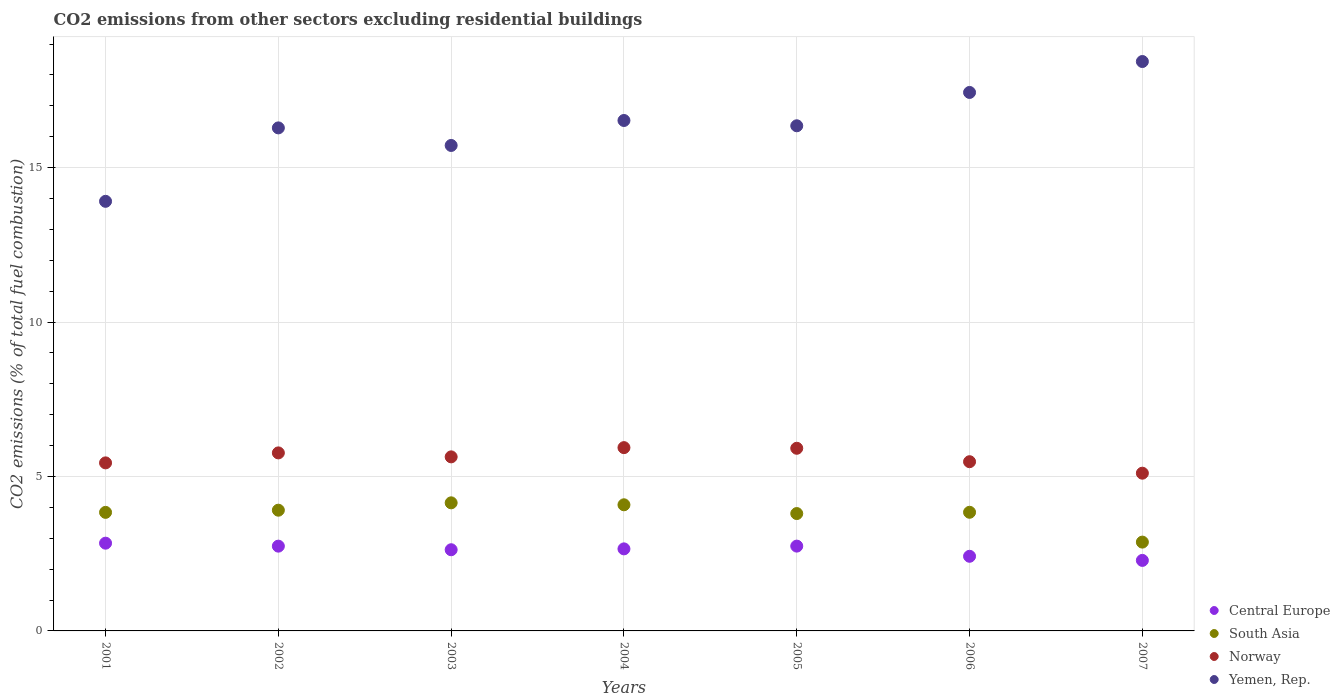How many different coloured dotlines are there?
Keep it short and to the point. 4. Is the number of dotlines equal to the number of legend labels?
Keep it short and to the point. Yes. What is the total CO2 emitted in Yemen, Rep. in 2007?
Offer a very short reply. 18.43. Across all years, what is the maximum total CO2 emitted in Central Europe?
Offer a very short reply. 2.84. Across all years, what is the minimum total CO2 emitted in South Asia?
Offer a terse response. 2.88. In which year was the total CO2 emitted in Norway maximum?
Make the answer very short. 2004. What is the total total CO2 emitted in Yemen, Rep. in the graph?
Offer a terse response. 114.66. What is the difference between the total CO2 emitted in South Asia in 2003 and that in 2004?
Your answer should be very brief. 0.06. What is the difference between the total CO2 emitted in Norway in 2003 and the total CO2 emitted in Yemen, Rep. in 2001?
Your answer should be compact. -8.27. What is the average total CO2 emitted in Central Europe per year?
Give a very brief answer. 2.62. In the year 2004, what is the difference between the total CO2 emitted in Norway and total CO2 emitted in Yemen, Rep.?
Make the answer very short. -10.59. What is the ratio of the total CO2 emitted in South Asia in 2004 to that in 2006?
Make the answer very short. 1.06. Is the total CO2 emitted in Norway in 2003 less than that in 2004?
Your response must be concise. Yes. What is the difference between the highest and the second highest total CO2 emitted in Central Europe?
Offer a terse response. 0.09. What is the difference between the highest and the lowest total CO2 emitted in Yemen, Rep.?
Ensure brevity in your answer.  4.53. In how many years, is the total CO2 emitted in Yemen, Rep. greater than the average total CO2 emitted in Yemen, Rep. taken over all years?
Your answer should be compact. 3. Is the sum of the total CO2 emitted in South Asia in 2005 and 2007 greater than the maximum total CO2 emitted in Yemen, Rep. across all years?
Keep it short and to the point. No. Is it the case that in every year, the sum of the total CO2 emitted in Yemen, Rep. and total CO2 emitted in Norway  is greater than the sum of total CO2 emitted in Central Europe and total CO2 emitted in South Asia?
Your response must be concise. No. Does the total CO2 emitted in Norway monotonically increase over the years?
Provide a short and direct response. No. Is the total CO2 emitted in Norway strictly greater than the total CO2 emitted in Central Europe over the years?
Your response must be concise. Yes. Is the total CO2 emitted in South Asia strictly less than the total CO2 emitted in Central Europe over the years?
Offer a terse response. No. How many dotlines are there?
Offer a terse response. 4. What is the difference between two consecutive major ticks on the Y-axis?
Your answer should be very brief. 5. Are the values on the major ticks of Y-axis written in scientific E-notation?
Ensure brevity in your answer.  No. Does the graph contain any zero values?
Keep it short and to the point. No. How many legend labels are there?
Your answer should be very brief. 4. How are the legend labels stacked?
Provide a short and direct response. Vertical. What is the title of the graph?
Give a very brief answer. CO2 emissions from other sectors excluding residential buildings. What is the label or title of the Y-axis?
Ensure brevity in your answer.  CO2 emissions (% of total fuel combustion). What is the CO2 emissions (% of total fuel combustion) in Central Europe in 2001?
Provide a succinct answer. 2.84. What is the CO2 emissions (% of total fuel combustion) of South Asia in 2001?
Make the answer very short. 3.84. What is the CO2 emissions (% of total fuel combustion) in Norway in 2001?
Your answer should be very brief. 5.44. What is the CO2 emissions (% of total fuel combustion) in Yemen, Rep. in 2001?
Ensure brevity in your answer.  13.91. What is the CO2 emissions (% of total fuel combustion) of Central Europe in 2002?
Offer a terse response. 2.74. What is the CO2 emissions (% of total fuel combustion) of South Asia in 2002?
Make the answer very short. 3.91. What is the CO2 emissions (% of total fuel combustion) in Norway in 2002?
Provide a succinct answer. 5.76. What is the CO2 emissions (% of total fuel combustion) in Yemen, Rep. in 2002?
Your answer should be compact. 16.29. What is the CO2 emissions (% of total fuel combustion) in Central Europe in 2003?
Offer a terse response. 2.63. What is the CO2 emissions (% of total fuel combustion) of South Asia in 2003?
Offer a terse response. 4.15. What is the CO2 emissions (% of total fuel combustion) in Norway in 2003?
Your response must be concise. 5.63. What is the CO2 emissions (% of total fuel combustion) in Yemen, Rep. in 2003?
Offer a terse response. 15.72. What is the CO2 emissions (% of total fuel combustion) of Central Europe in 2004?
Provide a succinct answer. 2.66. What is the CO2 emissions (% of total fuel combustion) of South Asia in 2004?
Your answer should be very brief. 4.08. What is the CO2 emissions (% of total fuel combustion) in Norway in 2004?
Make the answer very short. 5.93. What is the CO2 emissions (% of total fuel combustion) of Yemen, Rep. in 2004?
Make the answer very short. 16.53. What is the CO2 emissions (% of total fuel combustion) of Central Europe in 2005?
Your answer should be compact. 2.75. What is the CO2 emissions (% of total fuel combustion) of South Asia in 2005?
Your response must be concise. 3.8. What is the CO2 emissions (% of total fuel combustion) of Norway in 2005?
Your answer should be very brief. 5.91. What is the CO2 emissions (% of total fuel combustion) in Yemen, Rep. in 2005?
Give a very brief answer. 16.35. What is the CO2 emissions (% of total fuel combustion) in Central Europe in 2006?
Make the answer very short. 2.42. What is the CO2 emissions (% of total fuel combustion) of South Asia in 2006?
Your answer should be compact. 3.84. What is the CO2 emissions (% of total fuel combustion) in Norway in 2006?
Make the answer very short. 5.48. What is the CO2 emissions (% of total fuel combustion) of Yemen, Rep. in 2006?
Give a very brief answer. 17.43. What is the CO2 emissions (% of total fuel combustion) of Central Europe in 2007?
Provide a succinct answer. 2.28. What is the CO2 emissions (% of total fuel combustion) of South Asia in 2007?
Provide a succinct answer. 2.88. What is the CO2 emissions (% of total fuel combustion) of Norway in 2007?
Ensure brevity in your answer.  5.11. What is the CO2 emissions (% of total fuel combustion) in Yemen, Rep. in 2007?
Your answer should be very brief. 18.43. Across all years, what is the maximum CO2 emissions (% of total fuel combustion) of Central Europe?
Keep it short and to the point. 2.84. Across all years, what is the maximum CO2 emissions (% of total fuel combustion) in South Asia?
Your answer should be compact. 4.15. Across all years, what is the maximum CO2 emissions (% of total fuel combustion) of Norway?
Offer a very short reply. 5.93. Across all years, what is the maximum CO2 emissions (% of total fuel combustion) in Yemen, Rep.?
Provide a short and direct response. 18.43. Across all years, what is the minimum CO2 emissions (% of total fuel combustion) in Central Europe?
Offer a very short reply. 2.28. Across all years, what is the minimum CO2 emissions (% of total fuel combustion) of South Asia?
Your response must be concise. 2.88. Across all years, what is the minimum CO2 emissions (% of total fuel combustion) in Norway?
Give a very brief answer. 5.11. Across all years, what is the minimum CO2 emissions (% of total fuel combustion) of Yemen, Rep.?
Provide a succinct answer. 13.91. What is the total CO2 emissions (% of total fuel combustion) in Central Europe in the graph?
Your answer should be very brief. 18.32. What is the total CO2 emissions (% of total fuel combustion) of South Asia in the graph?
Ensure brevity in your answer.  26.49. What is the total CO2 emissions (% of total fuel combustion) in Norway in the graph?
Your answer should be very brief. 39.27. What is the total CO2 emissions (% of total fuel combustion) of Yemen, Rep. in the graph?
Keep it short and to the point. 114.66. What is the difference between the CO2 emissions (% of total fuel combustion) in Central Europe in 2001 and that in 2002?
Your response must be concise. 0.1. What is the difference between the CO2 emissions (% of total fuel combustion) in South Asia in 2001 and that in 2002?
Your answer should be very brief. -0.07. What is the difference between the CO2 emissions (% of total fuel combustion) of Norway in 2001 and that in 2002?
Provide a short and direct response. -0.32. What is the difference between the CO2 emissions (% of total fuel combustion) of Yemen, Rep. in 2001 and that in 2002?
Provide a short and direct response. -2.38. What is the difference between the CO2 emissions (% of total fuel combustion) of Central Europe in 2001 and that in 2003?
Give a very brief answer. 0.21. What is the difference between the CO2 emissions (% of total fuel combustion) in South Asia in 2001 and that in 2003?
Your response must be concise. -0.31. What is the difference between the CO2 emissions (% of total fuel combustion) in Norway in 2001 and that in 2003?
Make the answer very short. -0.19. What is the difference between the CO2 emissions (% of total fuel combustion) in Yemen, Rep. in 2001 and that in 2003?
Your response must be concise. -1.81. What is the difference between the CO2 emissions (% of total fuel combustion) of Central Europe in 2001 and that in 2004?
Your response must be concise. 0.18. What is the difference between the CO2 emissions (% of total fuel combustion) of South Asia in 2001 and that in 2004?
Keep it short and to the point. -0.25. What is the difference between the CO2 emissions (% of total fuel combustion) in Norway in 2001 and that in 2004?
Make the answer very short. -0.49. What is the difference between the CO2 emissions (% of total fuel combustion) of Yemen, Rep. in 2001 and that in 2004?
Offer a terse response. -2.62. What is the difference between the CO2 emissions (% of total fuel combustion) in Central Europe in 2001 and that in 2005?
Your answer should be very brief. 0.09. What is the difference between the CO2 emissions (% of total fuel combustion) of South Asia in 2001 and that in 2005?
Provide a succinct answer. 0.04. What is the difference between the CO2 emissions (% of total fuel combustion) in Norway in 2001 and that in 2005?
Provide a short and direct response. -0.47. What is the difference between the CO2 emissions (% of total fuel combustion) of Yemen, Rep. in 2001 and that in 2005?
Ensure brevity in your answer.  -2.45. What is the difference between the CO2 emissions (% of total fuel combustion) in Central Europe in 2001 and that in 2006?
Offer a terse response. 0.42. What is the difference between the CO2 emissions (% of total fuel combustion) in South Asia in 2001 and that in 2006?
Provide a short and direct response. -0. What is the difference between the CO2 emissions (% of total fuel combustion) in Norway in 2001 and that in 2006?
Give a very brief answer. -0.04. What is the difference between the CO2 emissions (% of total fuel combustion) in Yemen, Rep. in 2001 and that in 2006?
Give a very brief answer. -3.52. What is the difference between the CO2 emissions (% of total fuel combustion) in Central Europe in 2001 and that in 2007?
Your response must be concise. 0.56. What is the difference between the CO2 emissions (% of total fuel combustion) in South Asia in 2001 and that in 2007?
Provide a succinct answer. 0.96. What is the difference between the CO2 emissions (% of total fuel combustion) in Norway in 2001 and that in 2007?
Your answer should be compact. 0.33. What is the difference between the CO2 emissions (% of total fuel combustion) in Yemen, Rep. in 2001 and that in 2007?
Provide a succinct answer. -4.53. What is the difference between the CO2 emissions (% of total fuel combustion) of Central Europe in 2002 and that in 2003?
Offer a very short reply. 0.12. What is the difference between the CO2 emissions (% of total fuel combustion) of South Asia in 2002 and that in 2003?
Offer a terse response. -0.24. What is the difference between the CO2 emissions (% of total fuel combustion) of Norway in 2002 and that in 2003?
Offer a terse response. 0.13. What is the difference between the CO2 emissions (% of total fuel combustion) in Yemen, Rep. in 2002 and that in 2003?
Keep it short and to the point. 0.57. What is the difference between the CO2 emissions (% of total fuel combustion) in Central Europe in 2002 and that in 2004?
Make the answer very short. 0.09. What is the difference between the CO2 emissions (% of total fuel combustion) in South Asia in 2002 and that in 2004?
Provide a succinct answer. -0.17. What is the difference between the CO2 emissions (% of total fuel combustion) of Norway in 2002 and that in 2004?
Make the answer very short. -0.17. What is the difference between the CO2 emissions (% of total fuel combustion) in Yemen, Rep. in 2002 and that in 2004?
Provide a short and direct response. -0.24. What is the difference between the CO2 emissions (% of total fuel combustion) of Central Europe in 2002 and that in 2005?
Ensure brevity in your answer.  -0. What is the difference between the CO2 emissions (% of total fuel combustion) of South Asia in 2002 and that in 2005?
Offer a terse response. 0.11. What is the difference between the CO2 emissions (% of total fuel combustion) of Norway in 2002 and that in 2005?
Give a very brief answer. -0.15. What is the difference between the CO2 emissions (% of total fuel combustion) in Yemen, Rep. in 2002 and that in 2005?
Your response must be concise. -0.07. What is the difference between the CO2 emissions (% of total fuel combustion) in Central Europe in 2002 and that in 2006?
Offer a terse response. 0.33. What is the difference between the CO2 emissions (% of total fuel combustion) of South Asia in 2002 and that in 2006?
Offer a terse response. 0.07. What is the difference between the CO2 emissions (% of total fuel combustion) of Norway in 2002 and that in 2006?
Your response must be concise. 0.29. What is the difference between the CO2 emissions (% of total fuel combustion) in Yemen, Rep. in 2002 and that in 2006?
Offer a terse response. -1.15. What is the difference between the CO2 emissions (% of total fuel combustion) in Central Europe in 2002 and that in 2007?
Your answer should be very brief. 0.46. What is the difference between the CO2 emissions (% of total fuel combustion) of South Asia in 2002 and that in 2007?
Your response must be concise. 1.03. What is the difference between the CO2 emissions (% of total fuel combustion) in Norway in 2002 and that in 2007?
Make the answer very short. 0.66. What is the difference between the CO2 emissions (% of total fuel combustion) in Yemen, Rep. in 2002 and that in 2007?
Give a very brief answer. -2.15. What is the difference between the CO2 emissions (% of total fuel combustion) of Central Europe in 2003 and that in 2004?
Your answer should be very brief. -0.03. What is the difference between the CO2 emissions (% of total fuel combustion) in South Asia in 2003 and that in 2004?
Keep it short and to the point. 0.06. What is the difference between the CO2 emissions (% of total fuel combustion) of Norway in 2003 and that in 2004?
Keep it short and to the point. -0.3. What is the difference between the CO2 emissions (% of total fuel combustion) of Yemen, Rep. in 2003 and that in 2004?
Your answer should be compact. -0.81. What is the difference between the CO2 emissions (% of total fuel combustion) of Central Europe in 2003 and that in 2005?
Provide a short and direct response. -0.12. What is the difference between the CO2 emissions (% of total fuel combustion) in South Asia in 2003 and that in 2005?
Make the answer very short. 0.35. What is the difference between the CO2 emissions (% of total fuel combustion) in Norway in 2003 and that in 2005?
Keep it short and to the point. -0.28. What is the difference between the CO2 emissions (% of total fuel combustion) in Yemen, Rep. in 2003 and that in 2005?
Ensure brevity in your answer.  -0.64. What is the difference between the CO2 emissions (% of total fuel combustion) of Central Europe in 2003 and that in 2006?
Your response must be concise. 0.21. What is the difference between the CO2 emissions (% of total fuel combustion) in South Asia in 2003 and that in 2006?
Make the answer very short. 0.31. What is the difference between the CO2 emissions (% of total fuel combustion) of Norway in 2003 and that in 2006?
Your answer should be very brief. 0.16. What is the difference between the CO2 emissions (% of total fuel combustion) of Yemen, Rep. in 2003 and that in 2006?
Provide a short and direct response. -1.72. What is the difference between the CO2 emissions (% of total fuel combustion) in Central Europe in 2003 and that in 2007?
Give a very brief answer. 0.35. What is the difference between the CO2 emissions (% of total fuel combustion) in South Asia in 2003 and that in 2007?
Provide a short and direct response. 1.27. What is the difference between the CO2 emissions (% of total fuel combustion) in Norway in 2003 and that in 2007?
Give a very brief answer. 0.53. What is the difference between the CO2 emissions (% of total fuel combustion) of Yemen, Rep. in 2003 and that in 2007?
Provide a succinct answer. -2.72. What is the difference between the CO2 emissions (% of total fuel combustion) in Central Europe in 2004 and that in 2005?
Make the answer very short. -0.09. What is the difference between the CO2 emissions (% of total fuel combustion) of South Asia in 2004 and that in 2005?
Keep it short and to the point. 0.28. What is the difference between the CO2 emissions (% of total fuel combustion) in Norway in 2004 and that in 2005?
Provide a short and direct response. 0.02. What is the difference between the CO2 emissions (% of total fuel combustion) of Yemen, Rep. in 2004 and that in 2005?
Ensure brevity in your answer.  0.17. What is the difference between the CO2 emissions (% of total fuel combustion) in Central Europe in 2004 and that in 2006?
Ensure brevity in your answer.  0.24. What is the difference between the CO2 emissions (% of total fuel combustion) of South Asia in 2004 and that in 2006?
Your answer should be compact. 0.24. What is the difference between the CO2 emissions (% of total fuel combustion) of Norway in 2004 and that in 2006?
Your answer should be very brief. 0.46. What is the difference between the CO2 emissions (% of total fuel combustion) of Yemen, Rep. in 2004 and that in 2006?
Your answer should be compact. -0.91. What is the difference between the CO2 emissions (% of total fuel combustion) of Central Europe in 2004 and that in 2007?
Offer a very short reply. 0.37. What is the difference between the CO2 emissions (% of total fuel combustion) of South Asia in 2004 and that in 2007?
Keep it short and to the point. 1.21. What is the difference between the CO2 emissions (% of total fuel combustion) in Norway in 2004 and that in 2007?
Your answer should be very brief. 0.83. What is the difference between the CO2 emissions (% of total fuel combustion) of Yemen, Rep. in 2004 and that in 2007?
Provide a succinct answer. -1.91. What is the difference between the CO2 emissions (% of total fuel combustion) in Central Europe in 2005 and that in 2006?
Make the answer very short. 0.33. What is the difference between the CO2 emissions (% of total fuel combustion) in South Asia in 2005 and that in 2006?
Your answer should be compact. -0.04. What is the difference between the CO2 emissions (% of total fuel combustion) of Norway in 2005 and that in 2006?
Ensure brevity in your answer.  0.43. What is the difference between the CO2 emissions (% of total fuel combustion) of Yemen, Rep. in 2005 and that in 2006?
Your answer should be very brief. -1.08. What is the difference between the CO2 emissions (% of total fuel combustion) in Central Europe in 2005 and that in 2007?
Provide a succinct answer. 0.46. What is the difference between the CO2 emissions (% of total fuel combustion) in South Asia in 2005 and that in 2007?
Make the answer very short. 0.92. What is the difference between the CO2 emissions (% of total fuel combustion) of Norway in 2005 and that in 2007?
Ensure brevity in your answer.  0.81. What is the difference between the CO2 emissions (% of total fuel combustion) of Yemen, Rep. in 2005 and that in 2007?
Offer a terse response. -2.08. What is the difference between the CO2 emissions (% of total fuel combustion) in Central Europe in 2006 and that in 2007?
Your response must be concise. 0.13. What is the difference between the CO2 emissions (% of total fuel combustion) in South Asia in 2006 and that in 2007?
Your response must be concise. 0.97. What is the difference between the CO2 emissions (% of total fuel combustion) of Norway in 2006 and that in 2007?
Ensure brevity in your answer.  0.37. What is the difference between the CO2 emissions (% of total fuel combustion) in Yemen, Rep. in 2006 and that in 2007?
Offer a terse response. -1. What is the difference between the CO2 emissions (% of total fuel combustion) of Central Europe in 2001 and the CO2 emissions (% of total fuel combustion) of South Asia in 2002?
Give a very brief answer. -1.07. What is the difference between the CO2 emissions (% of total fuel combustion) in Central Europe in 2001 and the CO2 emissions (% of total fuel combustion) in Norway in 2002?
Your answer should be compact. -2.92. What is the difference between the CO2 emissions (% of total fuel combustion) of Central Europe in 2001 and the CO2 emissions (% of total fuel combustion) of Yemen, Rep. in 2002?
Your response must be concise. -13.44. What is the difference between the CO2 emissions (% of total fuel combustion) of South Asia in 2001 and the CO2 emissions (% of total fuel combustion) of Norway in 2002?
Provide a short and direct response. -1.93. What is the difference between the CO2 emissions (% of total fuel combustion) in South Asia in 2001 and the CO2 emissions (% of total fuel combustion) in Yemen, Rep. in 2002?
Your answer should be compact. -12.45. What is the difference between the CO2 emissions (% of total fuel combustion) of Norway in 2001 and the CO2 emissions (% of total fuel combustion) of Yemen, Rep. in 2002?
Keep it short and to the point. -10.85. What is the difference between the CO2 emissions (% of total fuel combustion) of Central Europe in 2001 and the CO2 emissions (% of total fuel combustion) of South Asia in 2003?
Offer a very short reply. -1.31. What is the difference between the CO2 emissions (% of total fuel combustion) of Central Europe in 2001 and the CO2 emissions (% of total fuel combustion) of Norway in 2003?
Your response must be concise. -2.79. What is the difference between the CO2 emissions (% of total fuel combustion) of Central Europe in 2001 and the CO2 emissions (% of total fuel combustion) of Yemen, Rep. in 2003?
Keep it short and to the point. -12.88. What is the difference between the CO2 emissions (% of total fuel combustion) in South Asia in 2001 and the CO2 emissions (% of total fuel combustion) in Norway in 2003?
Your answer should be very brief. -1.8. What is the difference between the CO2 emissions (% of total fuel combustion) of South Asia in 2001 and the CO2 emissions (% of total fuel combustion) of Yemen, Rep. in 2003?
Offer a terse response. -11.88. What is the difference between the CO2 emissions (% of total fuel combustion) in Norway in 2001 and the CO2 emissions (% of total fuel combustion) in Yemen, Rep. in 2003?
Your answer should be very brief. -10.28. What is the difference between the CO2 emissions (% of total fuel combustion) in Central Europe in 2001 and the CO2 emissions (% of total fuel combustion) in South Asia in 2004?
Offer a very short reply. -1.24. What is the difference between the CO2 emissions (% of total fuel combustion) in Central Europe in 2001 and the CO2 emissions (% of total fuel combustion) in Norway in 2004?
Provide a succinct answer. -3.09. What is the difference between the CO2 emissions (% of total fuel combustion) in Central Europe in 2001 and the CO2 emissions (% of total fuel combustion) in Yemen, Rep. in 2004?
Your answer should be very brief. -13.68. What is the difference between the CO2 emissions (% of total fuel combustion) in South Asia in 2001 and the CO2 emissions (% of total fuel combustion) in Norway in 2004?
Make the answer very short. -2.1. What is the difference between the CO2 emissions (% of total fuel combustion) of South Asia in 2001 and the CO2 emissions (% of total fuel combustion) of Yemen, Rep. in 2004?
Keep it short and to the point. -12.69. What is the difference between the CO2 emissions (% of total fuel combustion) in Norway in 2001 and the CO2 emissions (% of total fuel combustion) in Yemen, Rep. in 2004?
Give a very brief answer. -11.08. What is the difference between the CO2 emissions (% of total fuel combustion) in Central Europe in 2001 and the CO2 emissions (% of total fuel combustion) in South Asia in 2005?
Provide a succinct answer. -0.96. What is the difference between the CO2 emissions (% of total fuel combustion) of Central Europe in 2001 and the CO2 emissions (% of total fuel combustion) of Norway in 2005?
Make the answer very short. -3.07. What is the difference between the CO2 emissions (% of total fuel combustion) of Central Europe in 2001 and the CO2 emissions (% of total fuel combustion) of Yemen, Rep. in 2005?
Keep it short and to the point. -13.51. What is the difference between the CO2 emissions (% of total fuel combustion) in South Asia in 2001 and the CO2 emissions (% of total fuel combustion) in Norway in 2005?
Provide a short and direct response. -2.07. What is the difference between the CO2 emissions (% of total fuel combustion) of South Asia in 2001 and the CO2 emissions (% of total fuel combustion) of Yemen, Rep. in 2005?
Offer a very short reply. -12.52. What is the difference between the CO2 emissions (% of total fuel combustion) in Norway in 2001 and the CO2 emissions (% of total fuel combustion) in Yemen, Rep. in 2005?
Your answer should be compact. -10.91. What is the difference between the CO2 emissions (% of total fuel combustion) in Central Europe in 2001 and the CO2 emissions (% of total fuel combustion) in South Asia in 2006?
Offer a very short reply. -1. What is the difference between the CO2 emissions (% of total fuel combustion) in Central Europe in 2001 and the CO2 emissions (% of total fuel combustion) in Norway in 2006?
Keep it short and to the point. -2.64. What is the difference between the CO2 emissions (% of total fuel combustion) of Central Europe in 2001 and the CO2 emissions (% of total fuel combustion) of Yemen, Rep. in 2006?
Your answer should be very brief. -14.59. What is the difference between the CO2 emissions (% of total fuel combustion) of South Asia in 2001 and the CO2 emissions (% of total fuel combustion) of Norway in 2006?
Provide a short and direct response. -1.64. What is the difference between the CO2 emissions (% of total fuel combustion) of South Asia in 2001 and the CO2 emissions (% of total fuel combustion) of Yemen, Rep. in 2006?
Provide a short and direct response. -13.6. What is the difference between the CO2 emissions (% of total fuel combustion) in Norway in 2001 and the CO2 emissions (% of total fuel combustion) in Yemen, Rep. in 2006?
Provide a succinct answer. -11.99. What is the difference between the CO2 emissions (% of total fuel combustion) in Central Europe in 2001 and the CO2 emissions (% of total fuel combustion) in South Asia in 2007?
Your answer should be very brief. -0.03. What is the difference between the CO2 emissions (% of total fuel combustion) in Central Europe in 2001 and the CO2 emissions (% of total fuel combustion) in Norway in 2007?
Your response must be concise. -2.27. What is the difference between the CO2 emissions (% of total fuel combustion) of Central Europe in 2001 and the CO2 emissions (% of total fuel combustion) of Yemen, Rep. in 2007?
Offer a very short reply. -15.59. What is the difference between the CO2 emissions (% of total fuel combustion) of South Asia in 2001 and the CO2 emissions (% of total fuel combustion) of Norway in 2007?
Your response must be concise. -1.27. What is the difference between the CO2 emissions (% of total fuel combustion) of South Asia in 2001 and the CO2 emissions (% of total fuel combustion) of Yemen, Rep. in 2007?
Ensure brevity in your answer.  -14.6. What is the difference between the CO2 emissions (% of total fuel combustion) in Norway in 2001 and the CO2 emissions (% of total fuel combustion) in Yemen, Rep. in 2007?
Provide a short and direct response. -12.99. What is the difference between the CO2 emissions (% of total fuel combustion) of Central Europe in 2002 and the CO2 emissions (% of total fuel combustion) of South Asia in 2003?
Your response must be concise. -1.4. What is the difference between the CO2 emissions (% of total fuel combustion) in Central Europe in 2002 and the CO2 emissions (% of total fuel combustion) in Norway in 2003?
Give a very brief answer. -2.89. What is the difference between the CO2 emissions (% of total fuel combustion) in Central Europe in 2002 and the CO2 emissions (% of total fuel combustion) in Yemen, Rep. in 2003?
Your answer should be very brief. -12.97. What is the difference between the CO2 emissions (% of total fuel combustion) of South Asia in 2002 and the CO2 emissions (% of total fuel combustion) of Norway in 2003?
Provide a succinct answer. -1.73. What is the difference between the CO2 emissions (% of total fuel combustion) of South Asia in 2002 and the CO2 emissions (% of total fuel combustion) of Yemen, Rep. in 2003?
Your answer should be very brief. -11.81. What is the difference between the CO2 emissions (% of total fuel combustion) of Norway in 2002 and the CO2 emissions (% of total fuel combustion) of Yemen, Rep. in 2003?
Give a very brief answer. -9.95. What is the difference between the CO2 emissions (% of total fuel combustion) of Central Europe in 2002 and the CO2 emissions (% of total fuel combustion) of South Asia in 2004?
Make the answer very short. -1.34. What is the difference between the CO2 emissions (% of total fuel combustion) of Central Europe in 2002 and the CO2 emissions (% of total fuel combustion) of Norway in 2004?
Keep it short and to the point. -3.19. What is the difference between the CO2 emissions (% of total fuel combustion) of Central Europe in 2002 and the CO2 emissions (% of total fuel combustion) of Yemen, Rep. in 2004?
Provide a short and direct response. -13.78. What is the difference between the CO2 emissions (% of total fuel combustion) of South Asia in 2002 and the CO2 emissions (% of total fuel combustion) of Norway in 2004?
Provide a short and direct response. -2.03. What is the difference between the CO2 emissions (% of total fuel combustion) in South Asia in 2002 and the CO2 emissions (% of total fuel combustion) in Yemen, Rep. in 2004?
Your response must be concise. -12.62. What is the difference between the CO2 emissions (% of total fuel combustion) of Norway in 2002 and the CO2 emissions (% of total fuel combustion) of Yemen, Rep. in 2004?
Your answer should be compact. -10.76. What is the difference between the CO2 emissions (% of total fuel combustion) of Central Europe in 2002 and the CO2 emissions (% of total fuel combustion) of South Asia in 2005?
Make the answer very short. -1.06. What is the difference between the CO2 emissions (% of total fuel combustion) in Central Europe in 2002 and the CO2 emissions (% of total fuel combustion) in Norway in 2005?
Provide a succinct answer. -3.17. What is the difference between the CO2 emissions (% of total fuel combustion) of Central Europe in 2002 and the CO2 emissions (% of total fuel combustion) of Yemen, Rep. in 2005?
Make the answer very short. -13.61. What is the difference between the CO2 emissions (% of total fuel combustion) in South Asia in 2002 and the CO2 emissions (% of total fuel combustion) in Norway in 2005?
Give a very brief answer. -2. What is the difference between the CO2 emissions (% of total fuel combustion) in South Asia in 2002 and the CO2 emissions (% of total fuel combustion) in Yemen, Rep. in 2005?
Your response must be concise. -12.45. What is the difference between the CO2 emissions (% of total fuel combustion) in Norway in 2002 and the CO2 emissions (% of total fuel combustion) in Yemen, Rep. in 2005?
Provide a short and direct response. -10.59. What is the difference between the CO2 emissions (% of total fuel combustion) in Central Europe in 2002 and the CO2 emissions (% of total fuel combustion) in South Asia in 2006?
Give a very brief answer. -1.1. What is the difference between the CO2 emissions (% of total fuel combustion) in Central Europe in 2002 and the CO2 emissions (% of total fuel combustion) in Norway in 2006?
Offer a terse response. -2.73. What is the difference between the CO2 emissions (% of total fuel combustion) in Central Europe in 2002 and the CO2 emissions (% of total fuel combustion) in Yemen, Rep. in 2006?
Keep it short and to the point. -14.69. What is the difference between the CO2 emissions (% of total fuel combustion) of South Asia in 2002 and the CO2 emissions (% of total fuel combustion) of Norway in 2006?
Give a very brief answer. -1.57. What is the difference between the CO2 emissions (% of total fuel combustion) in South Asia in 2002 and the CO2 emissions (% of total fuel combustion) in Yemen, Rep. in 2006?
Your answer should be very brief. -13.52. What is the difference between the CO2 emissions (% of total fuel combustion) in Norway in 2002 and the CO2 emissions (% of total fuel combustion) in Yemen, Rep. in 2006?
Make the answer very short. -11.67. What is the difference between the CO2 emissions (% of total fuel combustion) of Central Europe in 2002 and the CO2 emissions (% of total fuel combustion) of South Asia in 2007?
Ensure brevity in your answer.  -0.13. What is the difference between the CO2 emissions (% of total fuel combustion) in Central Europe in 2002 and the CO2 emissions (% of total fuel combustion) in Norway in 2007?
Offer a very short reply. -2.36. What is the difference between the CO2 emissions (% of total fuel combustion) of Central Europe in 2002 and the CO2 emissions (% of total fuel combustion) of Yemen, Rep. in 2007?
Your answer should be compact. -15.69. What is the difference between the CO2 emissions (% of total fuel combustion) of South Asia in 2002 and the CO2 emissions (% of total fuel combustion) of Norway in 2007?
Provide a succinct answer. -1.2. What is the difference between the CO2 emissions (% of total fuel combustion) of South Asia in 2002 and the CO2 emissions (% of total fuel combustion) of Yemen, Rep. in 2007?
Your answer should be very brief. -14.53. What is the difference between the CO2 emissions (% of total fuel combustion) in Norway in 2002 and the CO2 emissions (% of total fuel combustion) in Yemen, Rep. in 2007?
Your answer should be compact. -12.67. What is the difference between the CO2 emissions (% of total fuel combustion) in Central Europe in 2003 and the CO2 emissions (% of total fuel combustion) in South Asia in 2004?
Offer a terse response. -1.46. What is the difference between the CO2 emissions (% of total fuel combustion) of Central Europe in 2003 and the CO2 emissions (% of total fuel combustion) of Norway in 2004?
Keep it short and to the point. -3.31. What is the difference between the CO2 emissions (% of total fuel combustion) of Central Europe in 2003 and the CO2 emissions (% of total fuel combustion) of Yemen, Rep. in 2004?
Provide a short and direct response. -13.9. What is the difference between the CO2 emissions (% of total fuel combustion) in South Asia in 2003 and the CO2 emissions (% of total fuel combustion) in Norway in 2004?
Ensure brevity in your answer.  -1.79. What is the difference between the CO2 emissions (% of total fuel combustion) in South Asia in 2003 and the CO2 emissions (% of total fuel combustion) in Yemen, Rep. in 2004?
Provide a succinct answer. -12.38. What is the difference between the CO2 emissions (% of total fuel combustion) of Norway in 2003 and the CO2 emissions (% of total fuel combustion) of Yemen, Rep. in 2004?
Your answer should be very brief. -10.89. What is the difference between the CO2 emissions (% of total fuel combustion) of Central Europe in 2003 and the CO2 emissions (% of total fuel combustion) of South Asia in 2005?
Offer a terse response. -1.17. What is the difference between the CO2 emissions (% of total fuel combustion) of Central Europe in 2003 and the CO2 emissions (% of total fuel combustion) of Norway in 2005?
Your response must be concise. -3.28. What is the difference between the CO2 emissions (% of total fuel combustion) in Central Europe in 2003 and the CO2 emissions (% of total fuel combustion) in Yemen, Rep. in 2005?
Make the answer very short. -13.73. What is the difference between the CO2 emissions (% of total fuel combustion) of South Asia in 2003 and the CO2 emissions (% of total fuel combustion) of Norway in 2005?
Keep it short and to the point. -1.77. What is the difference between the CO2 emissions (% of total fuel combustion) of South Asia in 2003 and the CO2 emissions (% of total fuel combustion) of Yemen, Rep. in 2005?
Give a very brief answer. -12.21. What is the difference between the CO2 emissions (% of total fuel combustion) in Norway in 2003 and the CO2 emissions (% of total fuel combustion) in Yemen, Rep. in 2005?
Offer a very short reply. -10.72. What is the difference between the CO2 emissions (% of total fuel combustion) of Central Europe in 2003 and the CO2 emissions (% of total fuel combustion) of South Asia in 2006?
Your response must be concise. -1.21. What is the difference between the CO2 emissions (% of total fuel combustion) of Central Europe in 2003 and the CO2 emissions (% of total fuel combustion) of Norway in 2006?
Ensure brevity in your answer.  -2.85. What is the difference between the CO2 emissions (% of total fuel combustion) of Central Europe in 2003 and the CO2 emissions (% of total fuel combustion) of Yemen, Rep. in 2006?
Offer a terse response. -14.8. What is the difference between the CO2 emissions (% of total fuel combustion) of South Asia in 2003 and the CO2 emissions (% of total fuel combustion) of Norway in 2006?
Offer a terse response. -1.33. What is the difference between the CO2 emissions (% of total fuel combustion) in South Asia in 2003 and the CO2 emissions (% of total fuel combustion) in Yemen, Rep. in 2006?
Your answer should be very brief. -13.29. What is the difference between the CO2 emissions (% of total fuel combustion) in Norway in 2003 and the CO2 emissions (% of total fuel combustion) in Yemen, Rep. in 2006?
Make the answer very short. -11.8. What is the difference between the CO2 emissions (% of total fuel combustion) of Central Europe in 2003 and the CO2 emissions (% of total fuel combustion) of South Asia in 2007?
Offer a very short reply. -0.25. What is the difference between the CO2 emissions (% of total fuel combustion) in Central Europe in 2003 and the CO2 emissions (% of total fuel combustion) in Norway in 2007?
Keep it short and to the point. -2.48. What is the difference between the CO2 emissions (% of total fuel combustion) of Central Europe in 2003 and the CO2 emissions (% of total fuel combustion) of Yemen, Rep. in 2007?
Ensure brevity in your answer.  -15.81. What is the difference between the CO2 emissions (% of total fuel combustion) in South Asia in 2003 and the CO2 emissions (% of total fuel combustion) in Norway in 2007?
Provide a short and direct response. -0.96. What is the difference between the CO2 emissions (% of total fuel combustion) of South Asia in 2003 and the CO2 emissions (% of total fuel combustion) of Yemen, Rep. in 2007?
Ensure brevity in your answer.  -14.29. What is the difference between the CO2 emissions (% of total fuel combustion) in Norway in 2003 and the CO2 emissions (% of total fuel combustion) in Yemen, Rep. in 2007?
Your response must be concise. -12.8. What is the difference between the CO2 emissions (% of total fuel combustion) in Central Europe in 2004 and the CO2 emissions (% of total fuel combustion) in South Asia in 2005?
Your response must be concise. -1.14. What is the difference between the CO2 emissions (% of total fuel combustion) of Central Europe in 2004 and the CO2 emissions (% of total fuel combustion) of Norway in 2005?
Your answer should be very brief. -3.26. What is the difference between the CO2 emissions (% of total fuel combustion) in Central Europe in 2004 and the CO2 emissions (% of total fuel combustion) in Yemen, Rep. in 2005?
Give a very brief answer. -13.7. What is the difference between the CO2 emissions (% of total fuel combustion) in South Asia in 2004 and the CO2 emissions (% of total fuel combustion) in Norway in 2005?
Make the answer very short. -1.83. What is the difference between the CO2 emissions (% of total fuel combustion) of South Asia in 2004 and the CO2 emissions (% of total fuel combustion) of Yemen, Rep. in 2005?
Your answer should be very brief. -12.27. What is the difference between the CO2 emissions (% of total fuel combustion) in Norway in 2004 and the CO2 emissions (% of total fuel combustion) in Yemen, Rep. in 2005?
Ensure brevity in your answer.  -10.42. What is the difference between the CO2 emissions (% of total fuel combustion) in Central Europe in 2004 and the CO2 emissions (% of total fuel combustion) in South Asia in 2006?
Provide a succinct answer. -1.19. What is the difference between the CO2 emissions (% of total fuel combustion) in Central Europe in 2004 and the CO2 emissions (% of total fuel combustion) in Norway in 2006?
Give a very brief answer. -2.82. What is the difference between the CO2 emissions (% of total fuel combustion) in Central Europe in 2004 and the CO2 emissions (% of total fuel combustion) in Yemen, Rep. in 2006?
Make the answer very short. -14.78. What is the difference between the CO2 emissions (% of total fuel combustion) in South Asia in 2004 and the CO2 emissions (% of total fuel combustion) in Norway in 2006?
Ensure brevity in your answer.  -1.39. What is the difference between the CO2 emissions (% of total fuel combustion) of South Asia in 2004 and the CO2 emissions (% of total fuel combustion) of Yemen, Rep. in 2006?
Offer a very short reply. -13.35. What is the difference between the CO2 emissions (% of total fuel combustion) of Norway in 2004 and the CO2 emissions (% of total fuel combustion) of Yemen, Rep. in 2006?
Offer a terse response. -11.5. What is the difference between the CO2 emissions (% of total fuel combustion) in Central Europe in 2004 and the CO2 emissions (% of total fuel combustion) in South Asia in 2007?
Ensure brevity in your answer.  -0.22. What is the difference between the CO2 emissions (% of total fuel combustion) in Central Europe in 2004 and the CO2 emissions (% of total fuel combustion) in Norway in 2007?
Your response must be concise. -2.45. What is the difference between the CO2 emissions (% of total fuel combustion) of Central Europe in 2004 and the CO2 emissions (% of total fuel combustion) of Yemen, Rep. in 2007?
Your answer should be compact. -15.78. What is the difference between the CO2 emissions (% of total fuel combustion) of South Asia in 2004 and the CO2 emissions (% of total fuel combustion) of Norway in 2007?
Provide a short and direct response. -1.02. What is the difference between the CO2 emissions (% of total fuel combustion) in South Asia in 2004 and the CO2 emissions (% of total fuel combustion) in Yemen, Rep. in 2007?
Offer a very short reply. -14.35. What is the difference between the CO2 emissions (% of total fuel combustion) in Norway in 2004 and the CO2 emissions (% of total fuel combustion) in Yemen, Rep. in 2007?
Provide a short and direct response. -12.5. What is the difference between the CO2 emissions (% of total fuel combustion) in Central Europe in 2005 and the CO2 emissions (% of total fuel combustion) in South Asia in 2006?
Provide a succinct answer. -1.1. What is the difference between the CO2 emissions (% of total fuel combustion) of Central Europe in 2005 and the CO2 emissions (% of total fuel combustion) of Norway in 2006?
Your answer should be compact. -2.73. What is the difference between the CO2 emissions (% of total fuel combustion) of Central Europe in 2005 and the CO2 emissions (% of total fuel combustion) of Yemen, Rep. in 2006?
Keep it short and to the point. -14.69. What is the difference between the CO2 emissions (% of total fuel combustion) in South Asia in 2005 and the CO2 emissions (% of total fuel combustion) in Norway in 2006?
Ensure brevity in your answer.  -1.68. What is the difference between the CO2 emissions (% of total fuel combustion) in South Asia in 2005 and the CO2 emissions (% of total fuel combustion) in Yemen, Rep. in 2006?
Make the answer very short. -13.63. What is the difference between the CO2 emissions (% of total fuel combustion) in Norway in 2005 and the CO2 emissions (% of total fuel combustion) in Yemen, Rep. in 2006?
Make the answer very short. -11.52. What is the difference between the CO2 emissions (% of total fuel combustion) of Central Europe in 2005 and the CO2 emissions (% of total fuel combustion) of South Asia in 2007?
Provide a short and direct response. -0.13. What is the difference between the CO2 emissions (% of total fuel combustion) of Central Europe in 2005 and the CO2 emissions (% of total fuel combustion) of Norway in 2007?
Your answer should be compact. -2.36. What is the difference between the CO2 emissions (% of total fuel combustion) of Central Europe in 2005 and the CO2 emissions (% of total fuel combustion) of Yemen, Rep. in 2007?
Offer a terse response. -15.69. What is the difference between the CO2 emissions (% of total fuel combustion) in South Asia in 2005 and the CO2 emissions (% of total fuel combustion) in Norway in 2007?
Provide a succinct answer. -1.31. What is the difference between the CO2 emissions (% of total fuel combustion) in South Asia in 2005 and the CO2 emissions (% of total fuel combustion) in Yemen, Rep. in 2007?
Provide a short and direct response. -14.63. What is the difference between the CO2 emissions (% of total fuel combustion) of Norway in 2005 and the CO2 emissions (% of total fuel combustion) of Yemen, Rep. in 2007?
Keep it short and to the point. -12.52. What is the difference between the CO2 emissions (% of total fuel combustion) of Central Europe in 2006 and the CO2 emissions (% of total fuel combustion) of South Asia in 2007?
Your answer should be very brief. -0.46. What is the difference between the CO2 emissions (% of total fuel combustion) in Central Europe in 2006 and the CO2 emissions (% of total fuel combustion) in Norway in 2007?
Keep it short and to the point. -2.69. What is the difference between the CO2 emissions (% of total fuel combustion) of Central Europe in 2006 and the CO2 emissions (% of total fuel combustion) of Yemen, Rep. in 2007?
Offer a terse response. -16.02. What is the difference between the CO2 emissions (% of total fuel combustion) in South Asia in 2006 and the CO2 emissions (% of total fuel combustion) in Norway in 2007?
Your response must be concise. -1.27. What is the difference between the CO2 emissions (% of total fuel combustion) in South Asia in 2006 and the CO2 emissions (% of total fuel combustion) in Yemen, Rep. in 2007?
Offer a terse response. -14.59. What is the difference between the CO2 emissions (% of total fuel combustion) in Norway in 2006 and the CO2 emissions (% of total fuel combustion) in Yemen, Rep. in 2007?
Your answer should be very brief. -12.96. What is the average CO2 emissions (% of total fuel combustion) in Central Europe per year?
Your response must be concise. 2.62. What is the average CO2 emissions (% of total fuel combustion) of South Asia per year?
Offer a terse response. 3.78. What is the average CO2 emissions (% of total fuel combustion) of Norway per year?
Offer a very short reply. 5.61. What is the average CO2 emissions (% of total fuel combustion) of Yemen, Rep. per year?
Your answer should be compact. 16.38. In the year 2001, what is the difference between the CO2 emissions (% of total fuel combustion) of Central Europe and CO2 emissions (% of total fuel combustion) of South Asia?
Your response must be concise. -1. In the year 2001, what is the difference between the CO2 emissions (% of total fuel combustion) in Central Europe and CO2 emissions (% of total fuel combustion) in Norway?
Give a very brief answer. -2.6. In the year 2001, what is the difference between the CO2 emissions (% of total fuel combustion) in Central Europe and CO2 emissions (% of total fuel combustion) in Yemen, Rep.?
Offer a terse response. -11.07. In the year 2001, what is the difference between the CO2 emissions (% of total fuel combustion) of South Asia and CO2 emissions (% of total fuel combustion) of Norway?
Keep it short and to the point. -1.6. In the year 2001, what is the difference between the CO2 emissions (% of total fuel combustion) of South Asia and CO2 emissions (% of total fuel combustion) of Yemen, Rep.?
Your answer should be compact. -10.07. In the year 2001, what is the difference between the CO2 emissions (% of total fuel combustion) in Norway and CO2 emissions (% of total fuel combustion) in Yemen, Rep.?
Keep it short and to the point. -8.47. In the year 2002, what is the difference between the CO2 emissions (% of total fuel combustion) of Central Europe and CO2 emissions (% of total fuel combustion) of South Asia?
Ensure brevity in your answer.  -1.16. In the year 2002, what is the difference between the CO2 emissions (% of total fuel combustion) in Central Europe and CO2 emissions (% of total fuel combustion) in Norway?
Make the answer very short. -3.02. In the year 2002, what is the difference between the CO2 emissions (% of total fuel combustion) in Central Europe and CO2 emissions (% of total fuel combustion) in Yemen, Rep.?
Your response must be concise. -13.54. In the year 2002, what is the difference between the CO2 emissions (% of total fuel combustion) in South Asia and CO2 emissions (% of total fuel combustion) in Norway?
Your answer should be very brief. -1.85. In the year 2002, what is the difference between the CO2 emissions (% of total fuel combustion) of South Asia and CO2 emissions (% of total fuel combustion) of Yemen, Rep.?
Offer a terse response. -12.38. In the year 2002, what is the difference between the CO2 emissions (% of total fuel combustion) in Norway and CO2 emissions (% of total fuel combustion) in Yemen, Rep.?
Your response must be concise. -10.52. In the year 2003, what is the difference between the CO2 emissions (% of total fuel combustion) of Central Europe and CO2 emissions (% of total fuel combustion) of South Asia?
Give a very brief answer. -1.52. In the year 2003, what is the difference between the CO2 emissions (% of total fuel combustion) of Central Europe and CO2 emissions (% of total fuel combustion) of Norway?
Your answer should be very brief. -3.01. In the year 2003, what is the difference between the CO2 emissions (% of total fuel combustion) in Central Europe and CO2 emissions (% of total fuel combustion) in Yemen, Rep.?
Your answer should be very brief. -13.09. In the year 2003, what is the difference between the CO2 emissions (% of total fuel combustion) of South Asia and CO2 emissions (% of total fuel combustion) of Norway?
Provide a short and direct response. -1.49. In the year 2003, what is the difference between the CO2 emissions (% of total fuel combustion) of South Asia and CO2 emissions (% of total fuel combustion) of Yemen, Rep.?
Your response must be concise. -11.57. In the year 2003, what is the difference between the CO2 emissions (% of total fuel combustion) of Norway and CO2 emissions (% of total fuel combustion) of Yemen, Rep.?
Your answer should be very brief. -10.08. In the year 2004, what is the difference between the CO2 emissions (% of total fuel combustion) of Central Europe and CO2 emissions (% of total fuel combustion) of South Asia?
Your answer should be compact. -1.43. In the year 2004, what is the difference between the CO2 emissions (% of total fuel combustion) in Central Europe and CO2 emissions (% of total fuel combustion) in Norway?
Keep it short and to the point. -3.28. In the year 2004, what is the difference between the CO2 emissions (% of total fuel combustion) in Central Europe and CO2 emissions (% of total fuel combustion) in Yemen, Rep.?
Provide a short and direct response. -13.87. In the year 2004, what is the difference between the CO2 emissions (% of total fuel combustion) of South Asia and CO2 emissions (% of total fuel combustion) of Norway?
Your answer should be compact. -1.85. In the year 2004, what is the difference between the CO2 emissions (% of total fuel combustion) of South Asia and CO2 emissions (% of total fuel combustion) of Yemen, Rep.?
Offer a very short reply. -12.44. In the year 2004, what is the difference between the CO2 emissions (% of total fuel combustion) of Norway and CO2 emissions (% of total fuel combustion) of Yemen, Rep.?
Keep it short and to the point. -10.59. In the year 2005, what is the difference between the CO2 emissions (% of total fuel combustion) in Central Europe and CO2 emissions (% of total fuel combustion) in South Asia?
Offer a terse response. -1.05. In the year 2005, what is the difference between the CO2 emissions (% of total fuel combustion) in Central Europe and CO2 emissions (% of total fuel combustion) in Norway?
Provide a succinct answer. -3.17. In the year 2005, what is the difference between the CO2 emissions (% of total fuel combustion) of Central Europe and CO2 emissions (% of total fuel combustion) of Yemen, Rep.?
Offer a terse response. -13.61. In the year 2005, what is the difference between the CO2 emissions (% of total fuel combustion) of South Asia and CO2 emissions (% of total fuel combustion) of Norway?
Provide a succinct answer. -2.11. In the year 2005, what is the difference between the CO2 emissions (% of total fuel combustion) of South Asia and CO2 emissions (% of total fuel combustion) of Yemen, Rep.?
Keep it short and to the point. -12.55. In the year 2005, what is the difference between the CO2 emissions (% of total fuel combustion) of Norway and CO2 emissions (% of total fuel combustion) of Yemen, Rep.?
Make the answer very short. -10.44. In the year 2006, what is the difference between the CO2 emissions (% of total fuel combustion) of Central Europe and CO2 emissions (% of total fuel combustion) of South Asia?
Provide a succinct answer. -1.42. In the year 2006, what is the difference between the CO2 emissions (% of total fuel combustion) in Central Europe and CO2 emissions (% of total fuel combustion) in Norway?
Your answer should be compact. -3.06. In the year 2006, what is the difference between the CO2 emissions (% of total fuel combustion) in Central Europe and CO2 emissions (% of total fuel combustion) in Yemen, Rep.?
Provide a succinct answer. -15.02. In the year 2006, what is the difference between the CO2 emissions (% of total fuel combustion) in South Asia and CO2 emissions (% of total fuel combustion) in Norway?
Offer a terse response. -1.64. In the year 2006, what is the difference between the CO2 emissions (% of total fuel combustion) of South Asia and CO2 emissions (% of total fuel combustion) of Yemen, Rep.?
Provide a short and direct response. -13.59. In the year 2006, what is the difference between the CO2 emissions (% of total fuel combustion) in Norway and CO2 emissions (% of total fuel combustion) in Yemen, Rep.?
Offer a terse response. -11.95. In the year 2007, what is the difference between the CO2 emissions (% of total fuel combustion) of Central Europe and CO2 emissions (% of total fuel combustion) of South Asia?
Your answer should be compact. -0.59. In the year 2007, what is the difference between the CO2 emissions (% of total fuel combustion) of Central Europe and CO2 emissions (% of total fuel combustion) of Norway?
Offer a very short reply. -2.82. In the year 2007, what is the difference between the CO2 emissions (% of total fuel combustion) of Central Europe and CO2 emissions (% of total fuel combustion) of Yemen, Rep.?
Ensure brevity in your answer.  -16.15. In the year 2007, what is the difference between the CO2 emissions (% of total fuel combustion) in South Asia and CO2 emissions (% of total fuel combustion) in Norway?
Make the answer very short. -2.23. In the year 2007, what is the difference between the CO2 emissions (% of total fuel combustion) in South Asia and CO2 emissions (% of total fuel combustion) in Yemen, Rep.?
Give a very brief answer. -15.56. In the year 2007, what is the difference between the CO2 emissions (% of total fuel combustion) in Norway and CO2 emissions (% of total fuel combustion) in Yemen, Rep.?
Your response must be concise. -13.33. What is the ratio of the CO2 emissions (% of total fuel combustion) of Central Europe in 2001 to that in 2002?
Provide a succinct answer. 1.03. What is the ratio of the CO2 emissions (% of total fuel combustion) of Norway in 2001 to that in 2002?
Keep it short and to the point. 0.94. What is the ratio of the CO2 emissions (% of total fuel combustion) in Yemen, Rep. in 2001 to that in 2002?
Your answer should be compact. 0.85. What is the ratio of the CO2 emissions (% of total fuel combustion) of Central Europe in 2001 to that in 2003?
Offer a very short reply. 1.08. What is the ratio of the CO2 emissions (% of total fuel combustion) in South Asia in 2001 to that in 2003?
Provide a succinct answer. 0.93. What is the ratio of the CO2 emissions (% of total fuel combustion) in Norway in 2001 to that in 2003?
Give a very brief answer. 0.97. What is the ratio of the CO2 emissions (% of total fuel combustion) of Yemen, Rep. in 2001 to that in 2003?
Give a very brief answer. 0.88. What is the ratio of the CO2 emissions (% of total fuel combustion) in Central Europe in 2001 to that in 2004?
Keep it short and to the point. 1.07. What is the ratio of the CO2 emissions (% of total fuel combustion) of South Asia in 2001 to that in 2004?
Offer a very short reply. 0.94. What is the ratio of the CO2 emissions (% of total fuel combustion) in Norway in 2001 to that in 2004?
Keep it short and to the point. 0.92. What is the ratio of the CO2 emissions (% of total fuel combustion) in Yemen, Rep. in 2001 to that in 2004?
Make the answer very short. 0.84. What is the ratio of the CO2 emissions (% of total fuel combustion) in Central Europe in 2001 to that in 2005?
Offer a terse response. 1.03. What is the ratio of the CO2 emissions (% of total fuel combustion) of South Asia in 2001 to that in 2005?
Offer a terse response. 1.01. What is the ratio of the CO2 emissions (% of total fuel combustion) of Norway in 2001 to that in 2005?
Provide a succinct answer. 0.92. What is the ratio of the CO2 emissions (% of total fuel combustion) in Yemen, Rep. in 2001 to that in 2005?
Provide a succinct answer. 0.85. What is the ratio of the CO2 emissions (% of total fuel combustion) in Central Europe in 2001 to that in 2006?
Offer a terse response. 1.18. What is the ratio of the CO2 emissions (% of total fuel combustion) of Yemen, Rep. in 2001 to that in 2006?
Offer a terse response. 0.8. What is the ratio of the CO2 emissions (% of total fuel combustion) of Central Europe in 2001 to that in 2007?
Your answer should be very brief. 1.24. What is the ratio of the CO2 emissions (% of total fuel combustion) in South Asia in 2001 to that in 2007?
Keep it short and to the point. 1.33. What is the ratio of the CO2 emissions (% of total fuel combustion) in Norway in 2001 to that in 2007?
Make the answer very short. 1.07. What is the ratio of the CO2 emissions (% of total fuel combustion) in Yemen, Rep. in 2001 to that in 2007?
Ensure brevity in your answer.  0.75. What is the ratio of the CO2 emissions (% of total fuel combustion) in Central Europe in 2002 to that in 2003?
Provide a succinct answer. 1.04. What is the ratio of the CO2 emissions (% of total fuel combustion) of South Asia in 2002 to that in 2003?
Your response must be concise. 0.94. What is the ratio of the CO2 emissions (% of total fuel combustion) of Norway in 2002 to that in 2003?
Your response must be concise. 1.02. What is the ratio of the CO2 emissions (% of total fuel combustion) in Yemen, Rep. in 2002 to that in 2003?
Give a very brief answer. 1.04. What is the ratio of the CO2 emissions (% of total fuel combustion) of South Asia in 2002 to that in 2004?
Offer a terse response. 0.96. What is the ratio of the CO2 emissions (% of total fuel combustion) of Norway in 2002 to that in 2004?
Offer a terse response. 0.97. What is the ratio of the CO2 emissions (% of total fuel combustion) in Yemen, Rep. in 2002 to that in 2004?
Your answer should be very brief. 0.99. What is the ratio of the CO2 emissions (% of total fuel combustion) in Central Europe in 2002 to that in 2005?
Your answer should be very brief. 1. What is the ratio of the CO2 emissions (% of total fuel combustion) of South Asia in 2002 to that in 2005?
Your answer should be compact. 1.03. What is the ratio of the CO2 emissions (% of total fuel combustion) of Norway in 2002 to that in 2005?
Make the answer very short. 0.97. What is the ratio of the CO2 emissions (% of total fuel combustion) of Central Europe in 2002 to that in 2006?
Your answer should be very brief. 1.14. What is the ratio of the CO2 emissions (% of total fuel combustion) of South Asia in 2002 to that in 2006?
Keep it short and to the point. 1.02. What is the ratio of the CO2 emissions (% of total fuel combustion) of Norway in 2002 to that in 2006?
Ensure brevity in your answer.  1.05. What is the ratio of the CO2 emissions (% of total fuel combustion) in Yemen, Rep. in 2002 to that in 2006?
Your answer should be very brief. 0.93. What is the ratio of the CO2 emissions (% of total fuel combustion) in Central Europe in 2002 to that in 2007?
Your answer should be very brief. 1.2. What is the ratio of the CO2 emissions (% of total fuel combustion) in South Asia in 2002 to that in 2007?
Provide a short and direct response. 1.36. What is the ratio of the CO2 emissions (% of total fuel combustion) in Norway in 2002 to that in 2007?
Ensure brevity in your answer.  1.13. What is the ratio of the CO2 emissions (% of total fuel combustion) in Yemen, Rep. in 2002 to that in 2007?
Your response must be concise. 0.88. What is the ratio of the CO2 emissions (% of total fuel combustion) of South Asia in 2003 to that in 2004?
Offer a very short reply. 1.02. What is the ratio of the CO2 emissions (% of total fuel combustion) of Norway in 2003 to that in 2004?
Make the answer very short. 0.95. What is the ratio of the CO2 emissions (% of total fuel combustion) in Yemen, Rep. in 2003 to that in 2004?
Keep it short and to the point. 0.95. What is the ratio of the CO2 emissions (% of total fuel combustion) of Central Europe in 2003 to that in 2005?
Your answer should be very brief. 0.96. What is the ratio of the CO2 emissions (% of total fuel combustion) of South Asia in 2003 to that in 2005?
Provide a short and direct response. 1.09. What is the ratio of the CO2 emissions (% of total fuel combustion) of Norway in 2003 to that in 2005?
Provide a succinct answer. 0.95. What is the ratio of the CO2 emissions (% of total fuel combustion) of Central Europe in 2003 to that in 2006?
Provide a succinct answer. 1.09. What is the ratio of the CO2 emissions (% of total fuel combustion) of South Asia in 2003 to that in 2006?
Make the answer very short. 1.08. What is the ratio of the CO2 emissions (% of total fuel combustion) of Norway in 2003 to that in 2006?
Your answer should be very brief. 1.03. What is the ratio of the CO2 emissions (% of total fuel combustion) of Yemen, Rep. in 2003 to that in 2006?
Provide a succinct answer. 0.9. What is the ratio of the CO2 emissions (% of total fuel combustion) of Central Europe in 2003 to that in 2007?
Keep it short and to the point. 1.15. What is the ratio of the CO2 emissions (% of total fuel combustion) of South Asia in 2003 to that in 2007?
Your response must be concise. 1.44. What is the ratio of the CO2 emissions (% of total fuel combustion) in Norway in 2003 to that in 2007?
Provide a succinct answer. 1.1. What is the ratio of the CO2 emissions (% of total fuel combustion) of Yemen, Rep. in 2003 to that in 2007?
Ensure brevity in your answer.  0.85. What is the ratio of the CO2 emissions (% of total fuel combustion) in Central Europe in 2004 to that in 2005?
Give a very brief answer. 0.97. What is the ratio of the CO2 emissions (% of total fuel combustion) of South Asia in 2004 to that in 2005?
Offer a terse response. 1.07. What is the ratio of the CO2 emissions (% of total fuel combustion) of Norway in 2004 to that in 2005?
Your answer should be very brief. 1. What is the ratio of the CO2 emissions (% of total fuel combustion) in Yemen, Rep. in 2004 to that in 2005?
Your response must be concise. 1.01. What is the ratio of the CO2 emissions (% of total fuel combustion) of Central Europe in 2004 to that in 2006?
Your answer should be very brief. 1.1. What is the ratio of the CO2 emissions (% of total fuel combustion) of South Asia in 2004 to that in 2006?
Keep it short and to the point. 1.06. What is the ratio of the CO2 emissions (% of total fuel combustion) in Norway in 2004 to that in 2006?
Give a very brief answer. 1.08. What is the ratio of the CO2 emissions (% of total fuel combustion) of Yemen, Rep. in 2004 to that in 2006?
Offer a very short reply. 0.95. What is the ratio of the CO2 emissions (% of total fuel combustion) of Central Europe in 2004 to that in 2007?
Provide a short and direct response. 1.16. What is the ratio of the CO2 emissions (% of total fuel combustion) in South Asia in 2004 to that in 2007?
Your answer should be compact. 1.42. What is the ratio of the CO2 emissions (% of total fuel combustion) in Norway in 2004 to that in 2007?
Your answer should be compact. 1.16. What is the ratio of the CO2 emissions (% of total fuel combustion) in Yemen, Rep. in 2004 to that in 2007?
Provide a short and direct response. 0.9. What is the ratio of the CO2 emissions (% of total fuel combustion) in Central Europe in 2005 to that in 2006?
Keep it short and to the point. 1.14. What is the ratio of the CO2 emissions (% of total fuel combustion) in Norway in 2005 to that in 2006?
Give a very brief answer. 1.08. What is the ratio of the CO2 emissions (% of total fuel combustion) of Yemen, Rep. in 2005 to that in 2006?
Provide a succinct answer. 0.94. What is the ratio of the CO2 emissions (% of total fuel combustion) of Central Europe in 2005 to that in 2007?
Provide a short and direct response. 1.2. What is the ratio of the CO2 emissions (% of total fuel combustion) of South Asia in 2005 to that in 2007?
Offer a very short reply. 1.32. What is the ratio of the CO2 emissions (% of total fuel combustion) of Norway in 2005 to that in 2007?
Provide a succinct answer. 1.16. What is the ratio of the CO2 emissions (% of total fuel combustion) in Yemen, Rep. in 2005 to that in 2007?
Your response must be concise. 0.89. What is the ratio of the CO2 emissions (% of total fuel combustion) of Central Europe in 2006 to that in 2007?
Make the answer very short. 1.06. What is the ratio of the CO2 emissions (% of total fuel combustion) of South Asia in 2006 to that in 2007?
Your answer should be compact. 1.34. What is the ratio of the CO2 emissions (% of total fuel combustion) in Norway in 2006 to that in 2007?
Make the answer very short. 1.07. What is the ratio of the CO2 emissions (% of total fuel combustion) in Yemen, Rep. in 2006 to that in 2007?
Provide a succinct answer. 0.95. What is the difference between the highest and the second highest CO2 emissions (% of total fuel combustion) of Central Europe?
Your response must be concise. 0.09. What is the difference between the highest and the second highest CO2 emissions (% of total fuel combustion) of South Asia?
Make the answer very short. 0.06. What is the difference between the highest and the second highest CO2 emissions (% of total fuel combustion) of Norway?
Your response must be concise. 0.02. What is the difference between the highest and the second highest CO2 emissions (% of total fuel combustion) in Yemen, Rep.?
Your response must be concise. 1. What is the difference between the highest and the lowest CO2 emissions (% of total fuel combustion) in Central Europe?
Your answer should be very brief. 0.56. What is the difference between the highest and the lowest CO2 emissions (% of total fuel combustion) in South Asia?
Give a very brief answer. 1.27. What is the difference between the highest and the lowest CO2 emissions (% of total fuel combustion) in Norway?
Offer a very short reply. 0.83. What is the difference between the highest and the lowest CO2 emissions (% of total fuel combustion) of Yemen, Rep.?
Your answer should be compact. 4.53. 